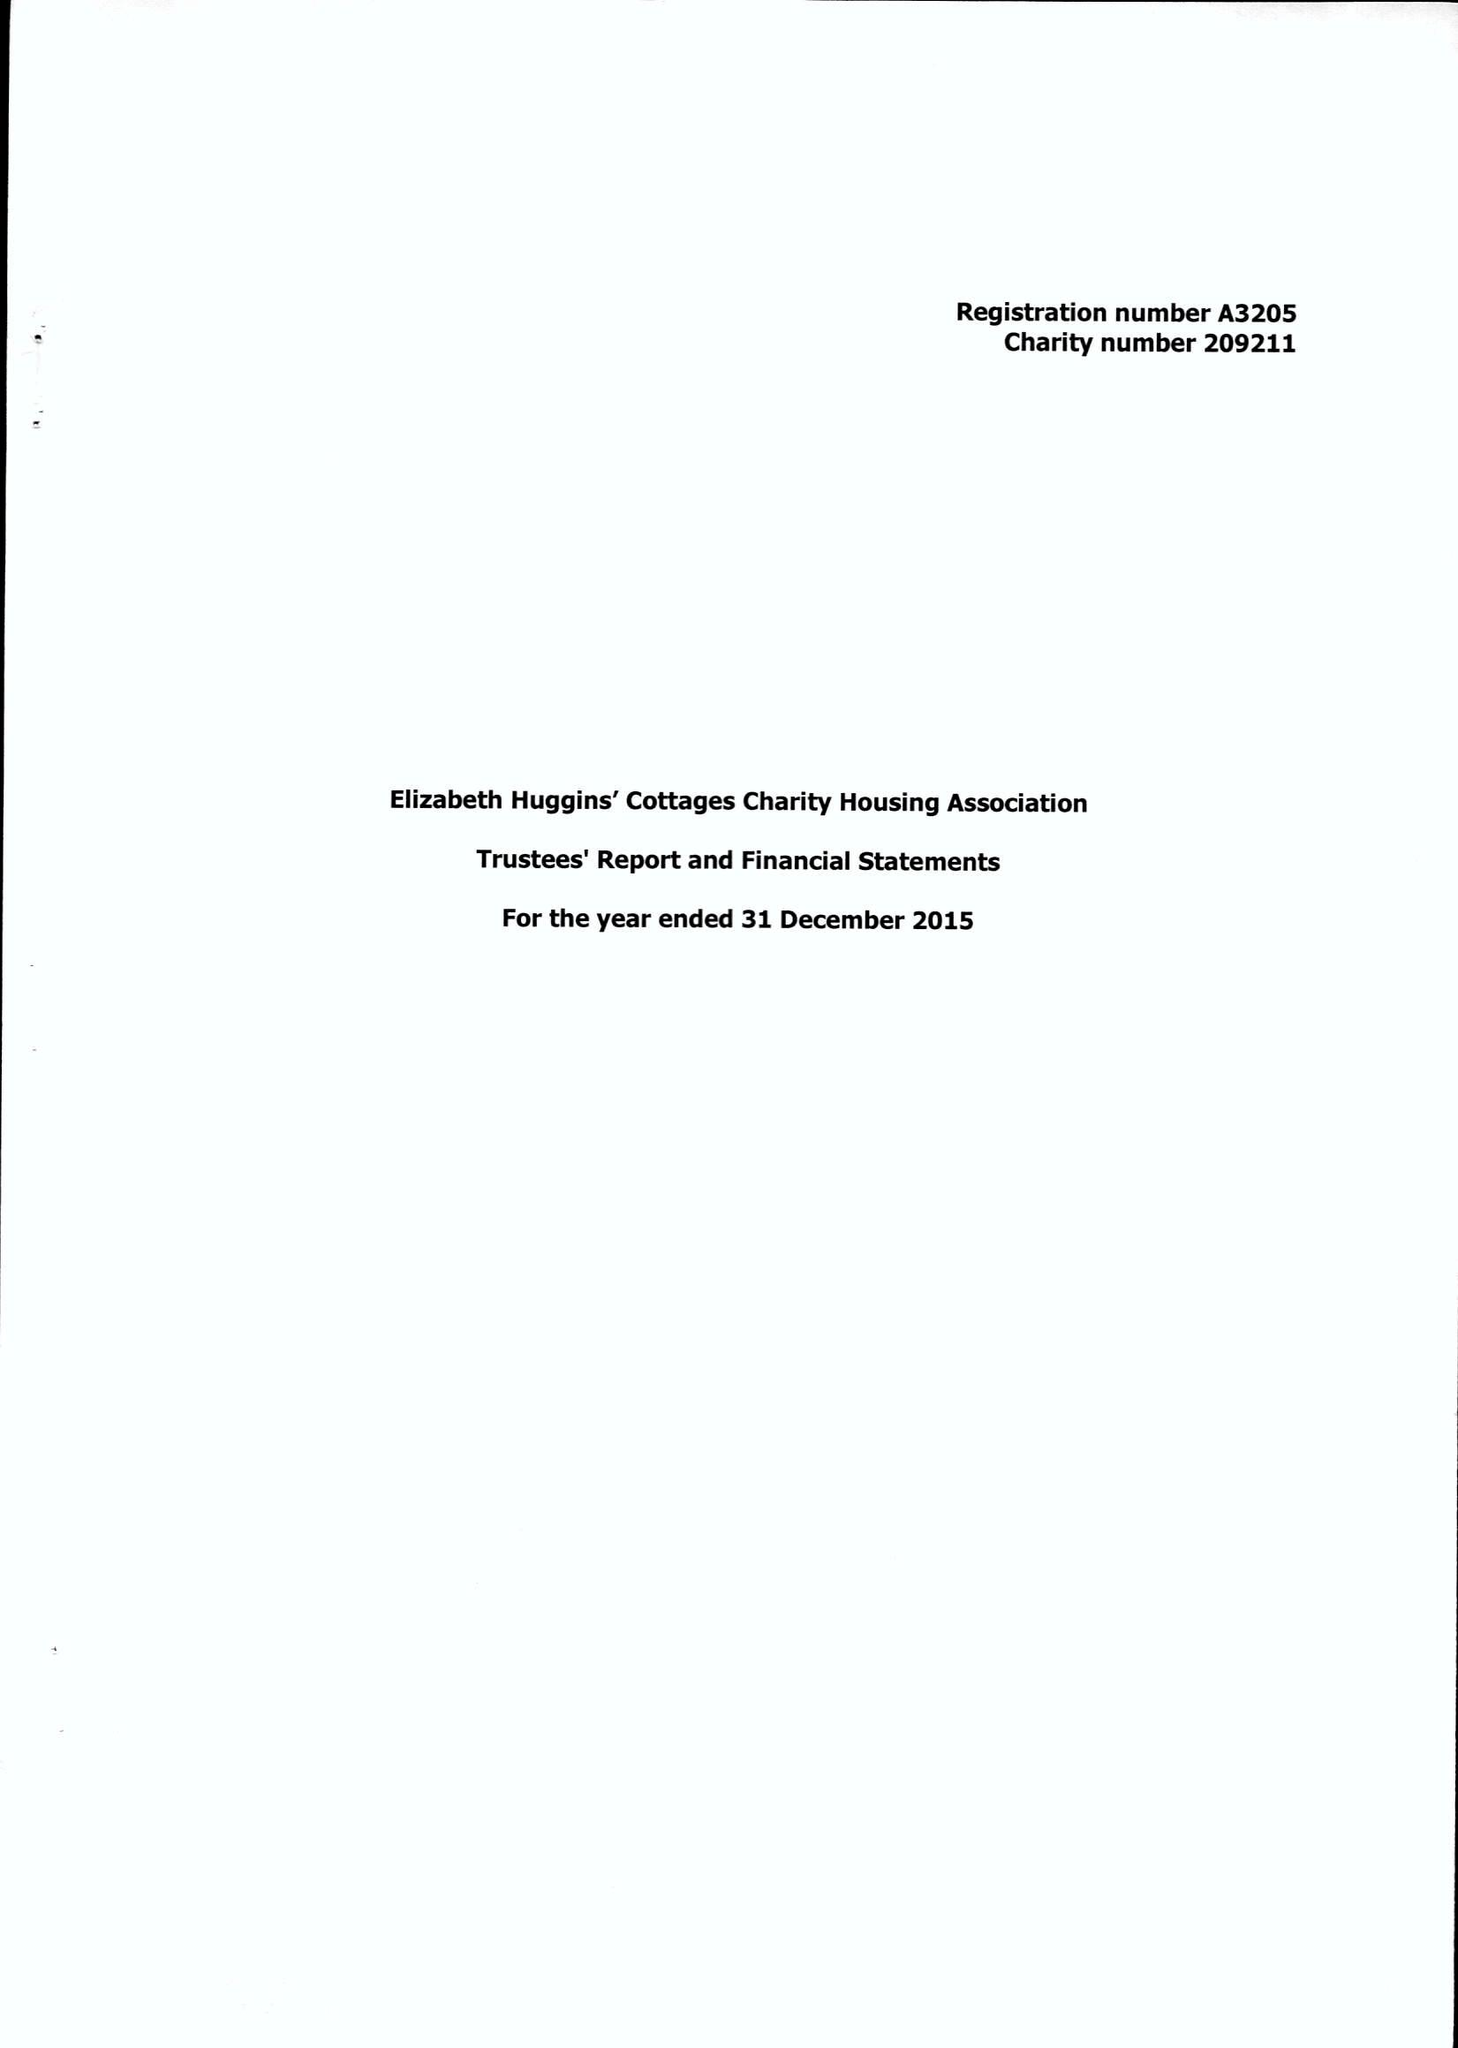What is the value for the income_annually_in_british_pounds?
Answer the question using a single word or phrase. 56500.00 